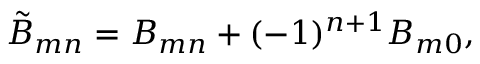<formula> <loc_0><loc_0><loc_500><loc_500>\tilde { B } _ { m n } = B _ { m n } + ( - 1 ) ^ { n + 1 } B _ { m 0 } ,</formula> 